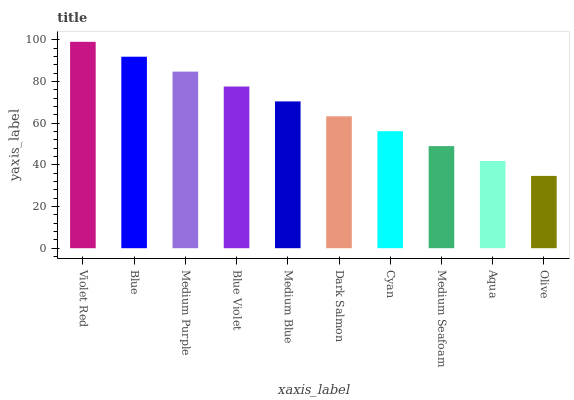Is Olive the minimum?
Answer yes or no. Yes. Is Violet Red the maximum?
Answer yes or no. Yes. Is Blue the minimum?
Answer yes or no. No. Is Blue the maximum?
Answer yes or no. No. Is Violet Red greater than Blue?
Answer yes or no. Yes. Is Blue less than Violet Red?
Answer yes or no. Yes. Is Blue greater than Violet Red?
Answer yes or no. No. Is Violet Red less than Blue?
Answer yes or no. No. Is Medium Blue the high median?
Answer yes or no. Yes. Is Dark Salmon the low median?
Answer yes or no. Yes. Is Aqua the high median?
Answer yes or no. No. Is Medium Purple the low median?
Answer yes or no. No. 